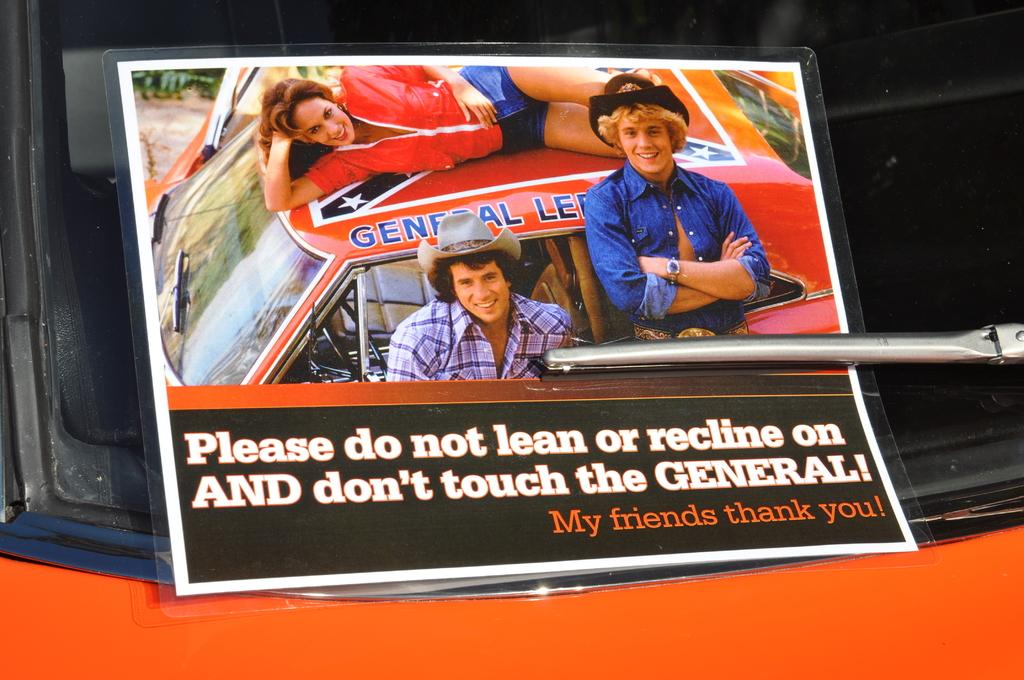What object is present in the image that typically holds a photograph? There is a photo frame in the image. Where is the photo frame located in the image? The photo frame is placed on a car's glass mirror. What can be observed about the people in the photo frame? The people in the photo frame are smiling. What type of chin can be seen on the card in the image? There is no card or chin present in the image; it features a photo frame with people smiling. 